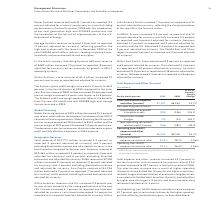According to International Business Machines's financial document, What event impacted the 2019 results? 2019 results were impacted by Red Hat purchase accounting and acquisition-related activity.. The document states: "* 2019 results were impacted by Red Hat purchase accounting and acquisition-related activity...." Also, What caused the year-to-year increase in the total expenses and other (income)? Based on the financial document, the answer is The year-to-year increase was a result of higher spending (15 points) driven by Red Hat (15 points) and higher acquisitionrelated charges and amortization of acquired intangible assets associated with the Red Hat transaction (4 points), partially offset by higher divestiture gains (3 points) and lower non-operating retirement-related costs (3 points).. Also, What caused total operating (non-GAAP) expense and other income to increase? driven by the higher spending, partially offset by the divestiture gains, as described above.. The document states: "come increased 14.7 percent year to year primarily driven by the higher spending, partially offset by the divestiture gains, as described above...." Also, can you calculate: What was the increase / (decrease) in Total consolidated expense and other (income) from 2018 to 2019? Based on the calculation: 7,107 - 6,253, the result is 854 (in millions). This is based on the information: "Total consolidated expense and other (income) $7,107 $6,253 13.7% l consolidated expense and other (income) $7,107 $6,253 13.7%..." The key data points involved are: 6,253, 7,107. Also, can you calculate: What is the average Amortization of acquired intangible assets? To answer this question, I need to perform calculations using the financial data. The calculation is: ( - 294 + (- 106)) / 2, which equals -200 (in millions). This is based on the information: "Amortization of acquired intangible assets (294) (106) 176.0 Amortization of acquired intangible assets (294) (106) 176.0 Amortization of acquired intangible assets (294) (106) 176.0..." The key data points involved are: 106, 294. Also, can you calculate: What is the average of Operating (non-GAAP) expense and other (income)? To answer this question, I need to perform calculations using the financial data. The calculation is: (6,591 + 5,746) / 2, which equals 6168.5 (in millions). This is based on the information: "ing (non-GAAP) expense and other (income) $6,591 $5,746 14.7% Operating (non-GAAP) expense and other (income) $6,591 $5,746 14.7%..." The key data points involved are: 5,746, 6,591. 